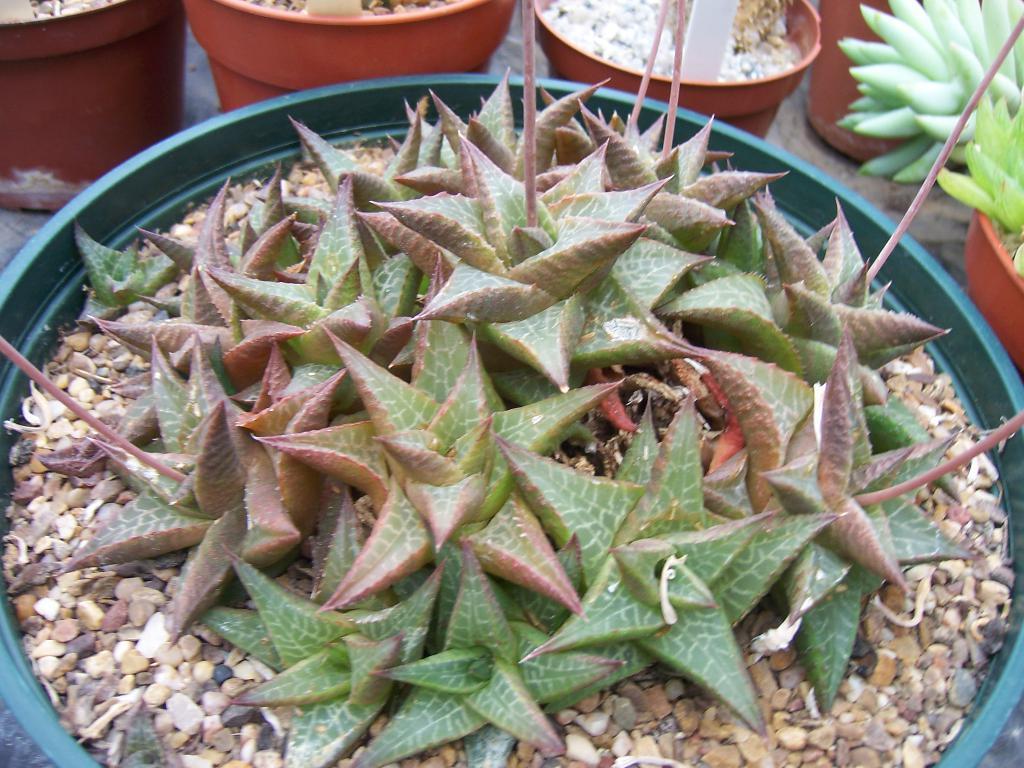Could you give a brief overview of what you see in this image? In this image we can see houseplants. 